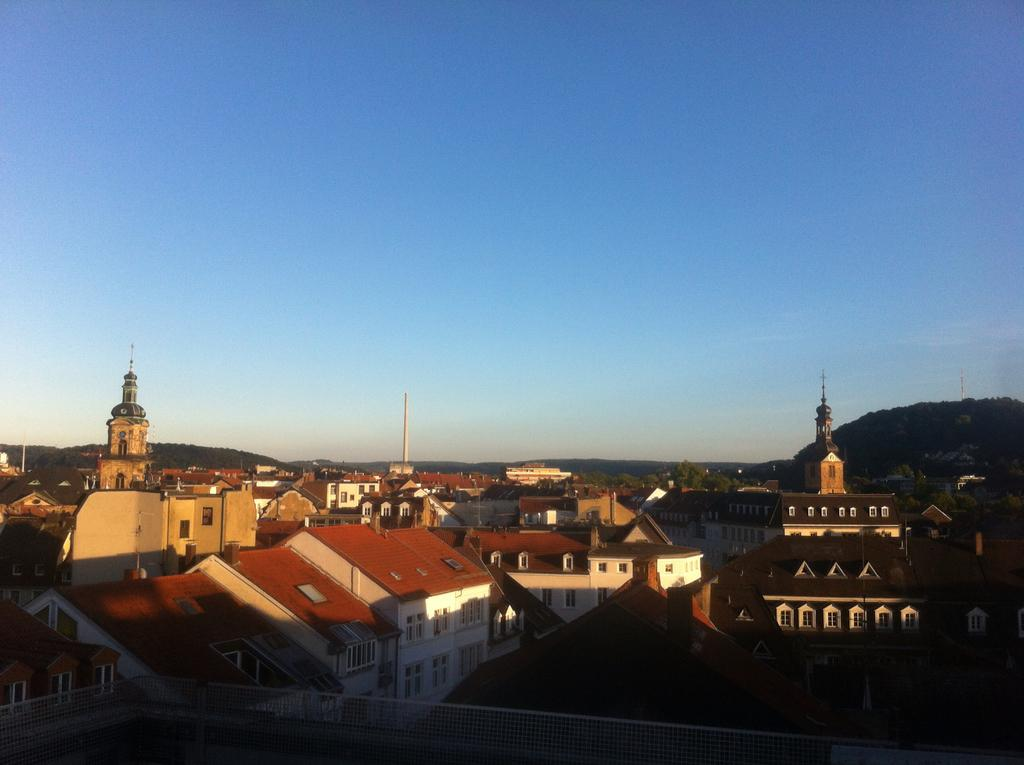What types of structures are located at the bottom of the image? There are buildings and houses at the bottom of the image. What tall structures can be seen in the image? There are towers in the image. What type of vegetation is present in the image? There are trees in the image. What architectural features can be seen in the image? There are windows and walls in the image. What is visible in the background of the image? The background of the image includes hills, and the sky is visible and clear. Where is the market located in the image? There is no market present in the image. What type of cemetery can be seen in the image? There is no cemetery present in the image. 